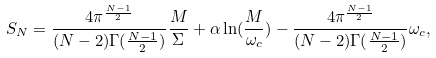<formula> <loc_0><loc_0><loc_500><loc_500>S _ { N } = \frac { 4 \pi ^ { \frac { N - 1 } { 2 } } } { ( N - 2 ) \Gamma ( \frac { N - 1 } { 2 } ) } \frac { M } { \Sigma } + \alpha \ln ( \frac { M } { \omega _ { c } } ) - \frac { 4 \pi ^ { \frac { N - 1 } { 2 } } } { ( N - 2 ) \Gamma ( \frac { N - 1 } { 2 } ) } \omega _ { c } ,</formula> 